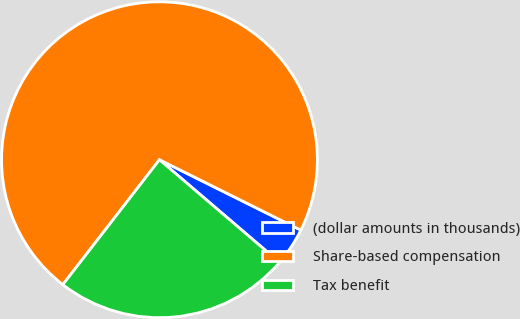Convert chart to OTSL. <chart><loc_0><loc_0><loc_500><loc_500><pie_chart><fcel>(dollar amounts in thousands)<fcel>Share-based compensation<fcel>Tax benefit<nl><fcel>3.91%<fcel>71.87%<fcel>24.22%<nl></chart> 